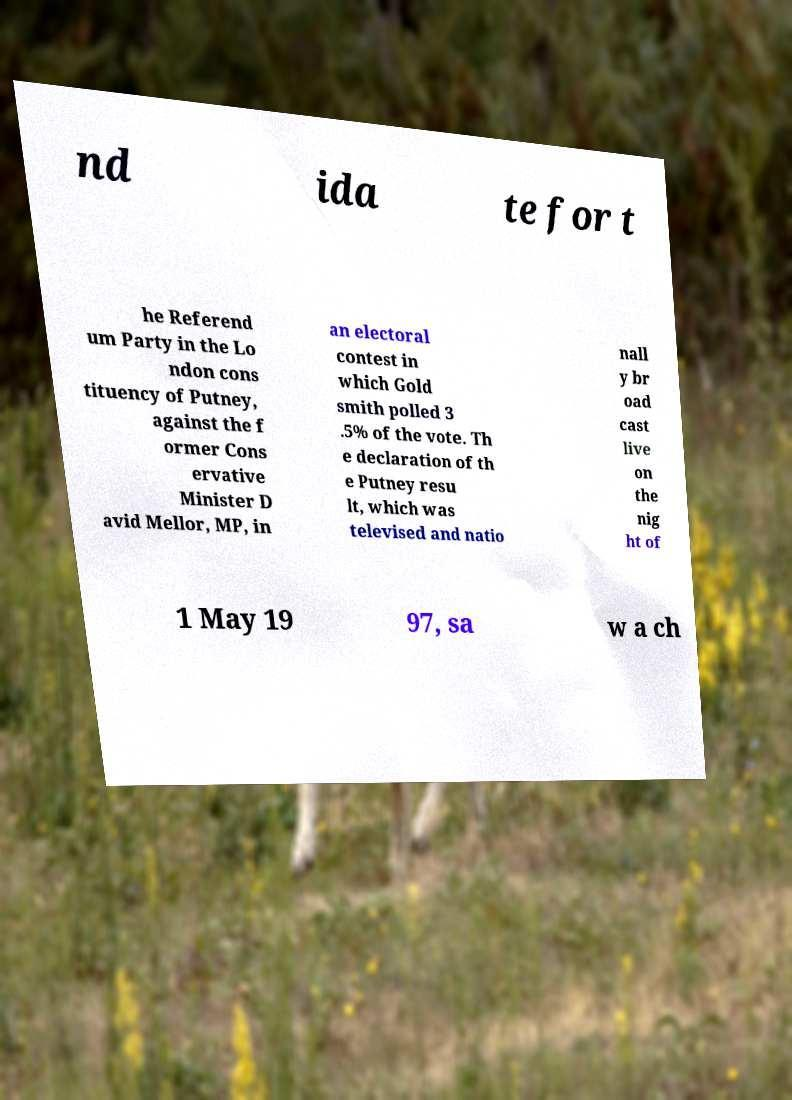There's text embedded in this image that I need extracted. Can you transcribe it verbatim? nd ida te for t he Referend um Party in the Lo ndon cons tituency of Putney, against the f ormer Cons ervative Minister D avid Mellor, MP, in an electoral contest in which Gold smith polled 3 .5% of the vote. Th e declaration of th e Putney resu lt, which was televised and natio nall y br oad cast live on the nig ht of 1 May 19 97, sa w a ch 